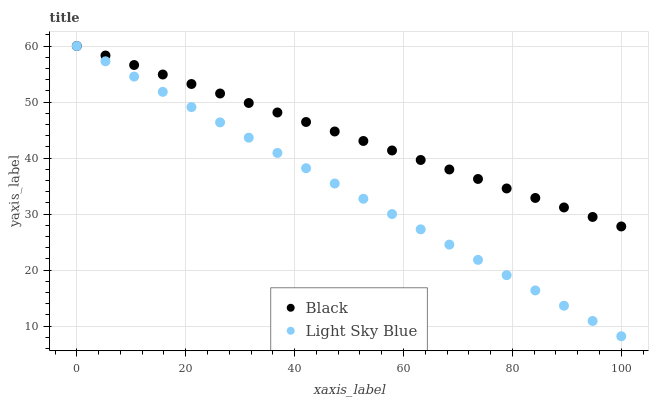Does Light Sky Blue have the minimum area under the curve?
Answer yes or no. Yes. Does Black have the maximum area under the curve?
Answer yes or no. Yes. Does Black have the minimum area under the curve?
Answer yes or no. No. Is Black the smoothest?
Answer yes or no. Yes. Is Light Sky Blue the roughest?
Answer yes or no. Yes. Is Black the roughest?
Answer yes or no. No. Does Light Sky Blue have the lowest value?
Answer yes or no. Yes. Does Black have the lowest value?
Answer yes or no. No. Does Black have the highest value?
Answer yes or no. Yes. Does Light Sky Blue intersect Black?
Answer yes or no. Yes. Is Light Sky Blue less than Black?
Answer yes or no. No. Is Light Sky Blue greater than Black?
Answer yes or no. No. 